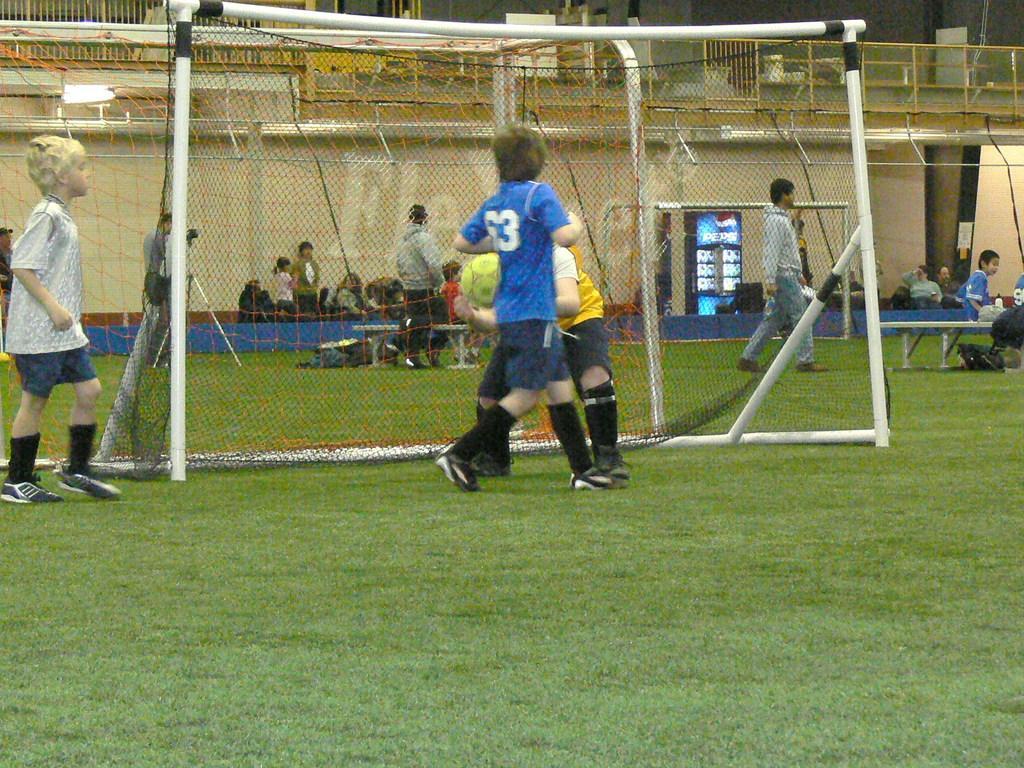Describe this image in one or two sentences. There are four kids on the ground playing football. And we can see a net beside them. Behind the net there are few people sitting and two members are walking. And to the right side there are some people sitting. In the background there is a building. 